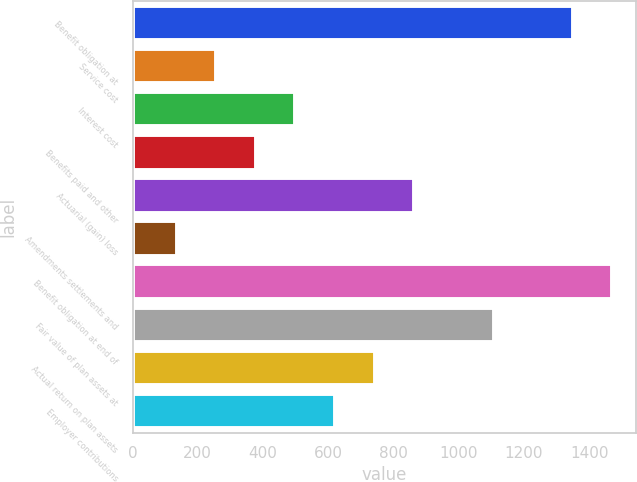<chart> <loc_0><loc_0><loc_500><loc_500><bar_chart><fcel>Benefit obligation at<fcel>Service cost<fcel>Interest cost<fcel>Benefits paid and other<fcel>Actuarial (gain) loss<fcel>Amendments settlements and<fcel>Benefit obligation at end of<fcel>Fair value of plan assets at<fcel>Actual return on plan assets<fcel>Employer contributions<nl><fcel>1349.68<fcel>256.36<fcel>499.32<fcel>377.84<fcel>863.76<fcel>134.88<fcel>1471.16<fcel>1106.72<fcel>742.28<fcel>620.8<nl></chart> 